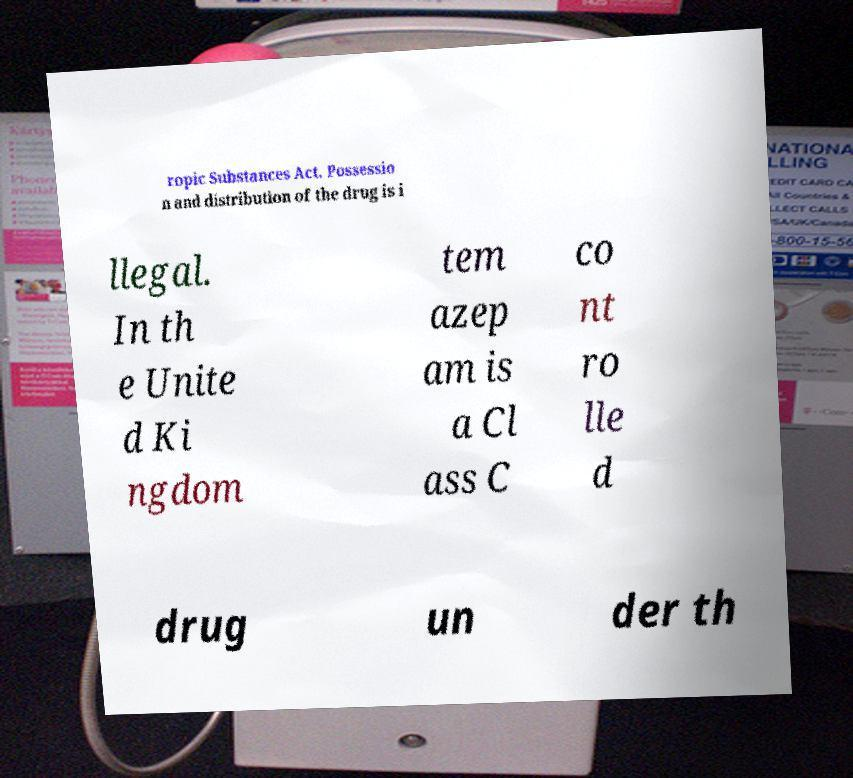What messages or text are displayed in this image? I need them in a readable, typed format. ropic Substances Act. Possessio n and distribution of the drug is i llegal. In th e Unite d Ki ngdom tem azep am is a Cl ass C co nt ro lle d drug un der th 